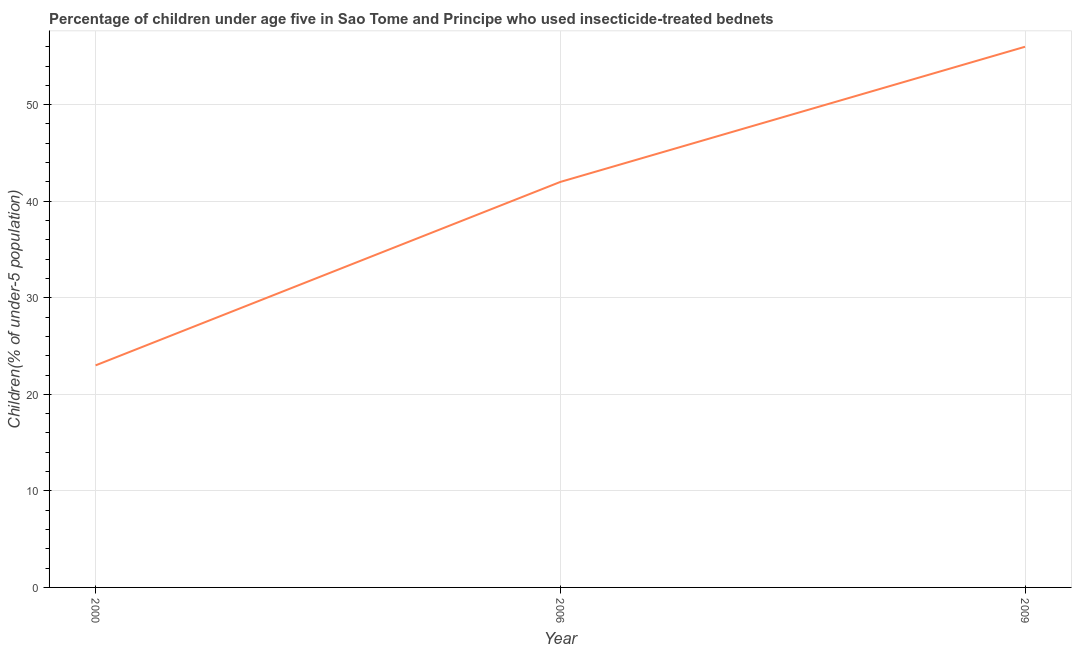What is the percentage of children who use of insecticide-treated bed nets in 2000?
Provide a succinct answer. 23. Across all years, what is the maximum percentage of children who use of insecticide-treated bed nets?
Offer a terse response. 56. Across all years, what is the minimum percentage of children who use of insecticide-treated bed nets?
Provide a succinct answer. 23. What is the sum of the percentage of children who use of insecticide-treated bed nets?
Your response must be concise. 121. What is the difference between the percentage of children who use of insecticide-treated bed nets in 2000 and 2006?
Give a very brief answer. -19. What is the average percentage of children who use of insecticide-treated bed nets per year?
Offer a very short reply. 40.33. What is the ratio of the percentage of children who use of insecticide-treated bed nets in 2006 to that in 2009?
Provide a succinct answer. 0.75. Is the difference between the percentage of children who use of insecticide-treated bed nets in 2000 and 2009 greater than the difference between any two years?
Your answer should be compact. Yes. Is the sum of the percentage of children who use of insecticide-treated bed nets in 2000 and 2009 greater than the maximum percentage of children who use of insecticide-treated bed nets across all years?
Your answer should be compact. Yes. What is the difference between the highest and the lowest percentage of children who use of insecticide-treated bed nets?
Offer a terse response. 33. In how many years, is the percentage of children who use of insecticide-treated bed nets greater than the average percentage of children who use of insecticide-treated bed nets taken over all years?
Give a very brief answer. 2. Does the percentage of children who use of insecticide-treated bed nets monotonically increase over the years?
Your answer should be compact. Yes. How many lines are there?
Your answer should be compact. 1. Does the graph contain any zero values?
Provide a succinct answer. No. Does the graph contain grids?
Provide a succinct answer. Yes. What is the title of the graph?
Keep it short and to the point. Percentage of children under age five in Sao Tome and Principe who used insecticide-treated bednets. What is the label or title of the Y-axis?
Your response must be concise. Children(% of under-5 population). What is the Children(% of under-5 population) of 2000?
Offer a terse response. 23. What is the Children(% of under-5 population) of 2006?
Make the answer very short. 42. What is the difference between the Children(% of under-5 population) in 2000 and 2009?
Offer a very short reply. -33. What is the difference between the Children(% of under-5 population) in 2006 and 2009?
Ensure brevity in your answer.  -14. What is the ratio of the Children(% of under-5 population) in 2000 to that in 2006?
Offer a terse response. 0.55. What is the ratio of the Children(% of under-5 population) in 2000 to that in 2009?
Your answer should be very brief. 0.41. 